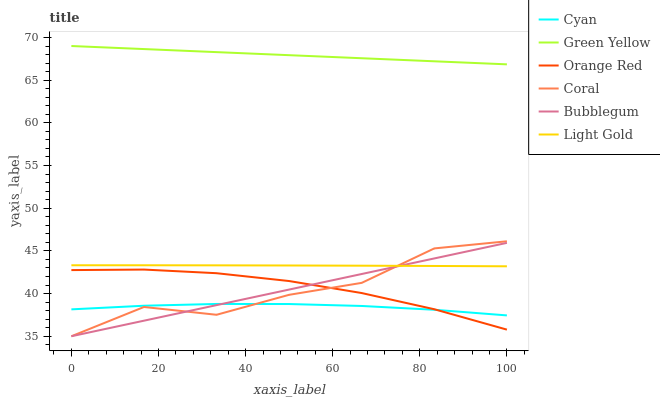Does Bubblegum have the minimum area under the curve?
Answer yes or no. No. Does Bubblegum have the maximum area under the curve?
Answer yes or no. No. Is Cyan the smoothest?
Answer yes or no. No. Is Cyan the roughest?
Answer yes or no. No. Does Cyan have the lowest value?
Answer yes or no. No. Does Bubblegum have the highest value?
Answer yes or no. No. Is Cyan less than Light Gold?
Answer yes or no. Yes. Is Light Gold greater than Orange Red?
Answer yes or no. Yes. Does Cyan intersect Light Gold?
Answer yes or no. No. 